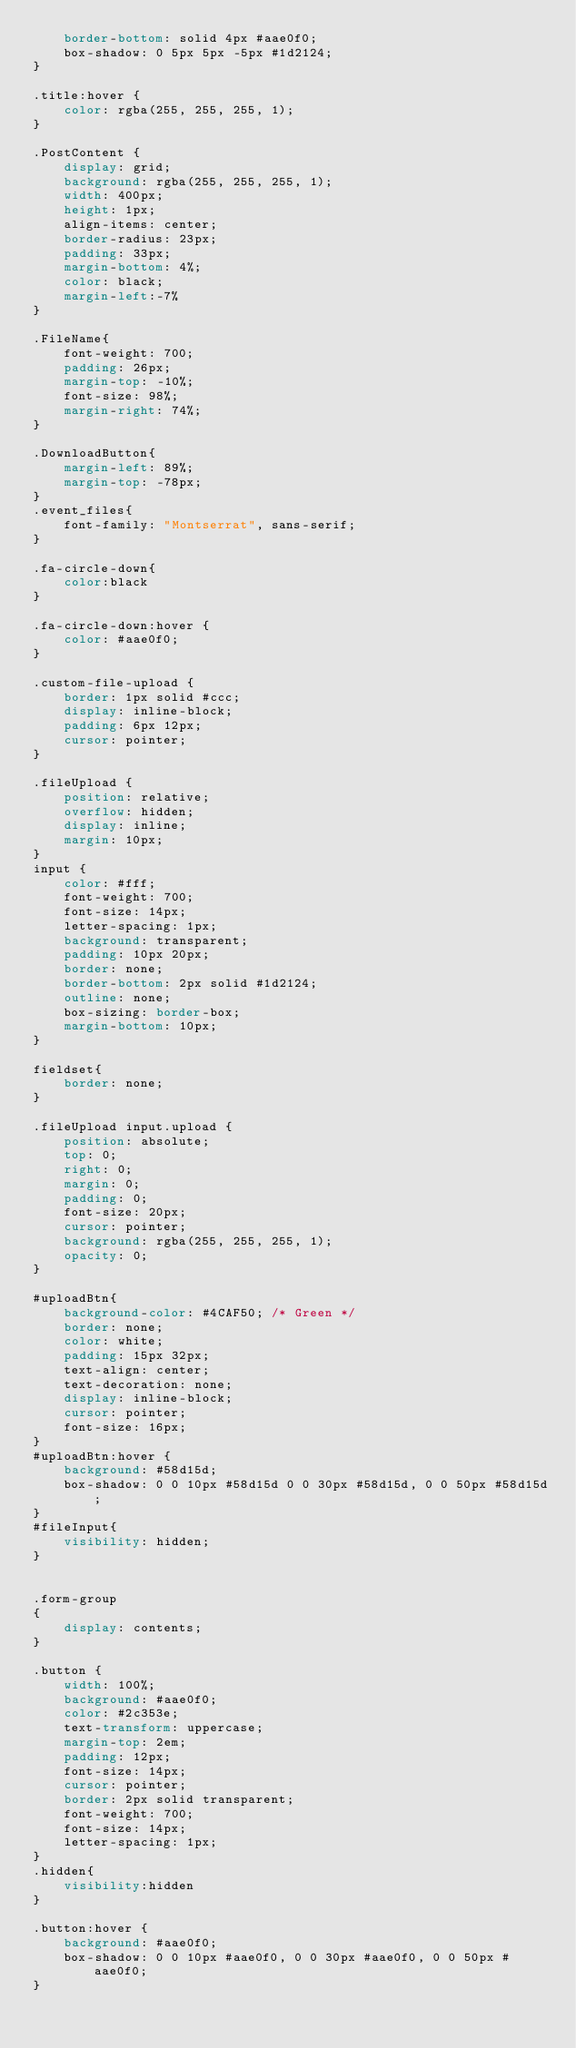<code> <loc_0><loc_0><loc_500><loc_500><_CSS_>    border-bottom: solid 4px #aae0f0;
    box-shadow: 0 5px 5px -5px #1d2124;
}

.title:hover {
    color: rgba(255, 255, 255, 1);
}

.PostContent {
    display: grid;
    background: rgba(255, 255, 255, 1);
    width: 400px;
    height: 1px;
    align-items: center;
    border-radius: 23px;
    padding: 33px;
    margin-bottom: 4%;
    color: black;
    margin-left:-7%
}

.FileName{
    font-weight: 700;
    padding: 26px;
    margin-top: -10%;
    font-size: 98%;
    margin-right: 74%;
}

.DownloadButton{
    margin-left: 89%;
    margin-top: -78px;
}
.event_files{
    font-family: "Montserrat", sans-serif;
}

.fa-circle-down{
    color:black
}

.fa-circle-down:hover {
    color: #aae0f0;
}

.custom-file-upload {
    border: 1px solid #ccc;
    display: inline-block;
    padding: 6px 12px;
    cursor: pointer;
}

.fileUpload {
    position: relative;
    overflow: hidden;
    display: inline;
    margin: 10px;
}
input {
    color: #fff;
    font-weight: 700;
    font-size: 14px;
    letter-spacing: 1px;
    background: transparent;
    padding: 10px 20px;
    border: none;
    border-bottom: 2px solid #1d2124;
    outline: none;
    box-sizing: border-box;
    margin-bottom: 10px;
}

fieldset{
    border: none;
}

.fileUpload input.upload {
    position: absolute;
    top: 0;
    right: 0;
    margin: 0;
    padding: 0;
    font-size: 20px;
    cursor: pointer;
    background: rgba(255, 255, 255, 1);
    opacity: 0;
}

#uploadBtn{
    background-color: #4CAF50; /* Green */
    border: none;
    color: white;
    padding: 15px 32px;
    text-align: center;
    text-decoration: none;
    display: inline-block;
    cursor: pointer;
    font-size: 16px;
}
#uploadBtn:hover {
    background: #58d15d;
    box-shadow: 0 0 10px #58d15d 0 0 30px #58d15d, 0 0 50px #58d15d;
}
#fileInput{
    visibility: hidden;
}


.form-group
{
    display: contents;
}

.button {
    width: 100%;
    background: #aae0f0;
    color: #2c353e;
    text-transform: uppercase;
    margin-top: 2em;
    padding: 12px;
    font-size: 14px;
    cursor: pointer;
    border: 2px solid transparent;
    font-weight: 700;
    font-size: 14px;
    letter-spacing: 1px;
}
.hidden{
    visibility:hidden
}

.button:hover {
    background: #aae0f0;
    box-shadow: 0 0 10px #aae0f0, 0 0 30px #aae0f0, 0 0 50px #aae0f0;
}
</code> 